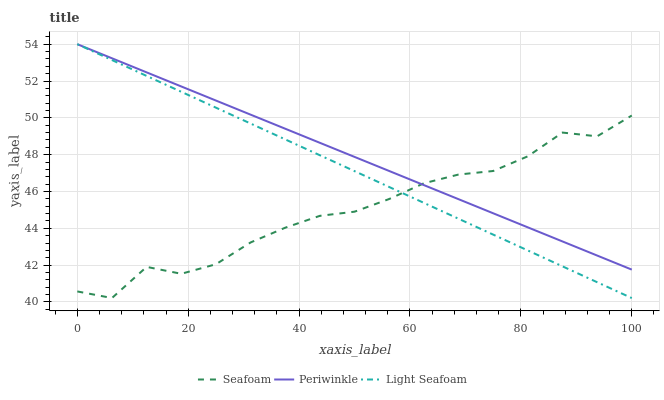Does Seafoam have the minimum area under the curve?
Answer yes or no. Yes. Does Periwinkle have the maximum area under the curve?
Answer yes or no. Yes. Does Periwinkle have the minimum area under the curve?
Answer yes or no. No. Does Seafoam have the maximum area under the curve?
Answer yes or no. No. Is Periwinkle the smoothest?
Answer yes or no. Yes. Is Seafoam the roughest?
Answer yes or no. Yes. Is Seafoam the smoothest?
Answer yes or no. No. Is Periwinkle the roughest?
Answer yes or no. No. Does Light Seafoam have the lowest value?
Answer yes or no. Yes. Does Seafoam have the lowest value?
Answer yes or no. No. Does Periwinkle have the highest value?
Answer yes or no. Yes. Does Seafoam have the highest value?
Answer yes or no. No. Does Seafoam intersect Periwinkle?
Answer yes or no. Yes. Is Seafoam less than Periwinkle?
Answer yes or no. No. Is Seafoam greater than Periwinkle?
Answer yes or no. No. 